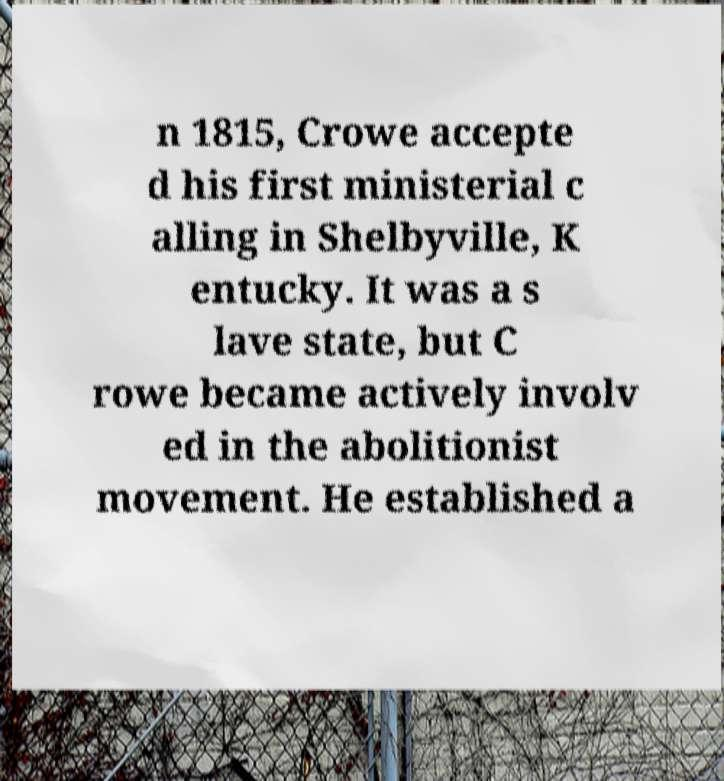Please read and relay the text visible in this image. What does it say? n 1815, Crowe accepte d his first ministerial c alling in Shelbyville, K entucky. It was a s lave state, but C rowe became actively involv ed in the abolitionist movement. He established a 